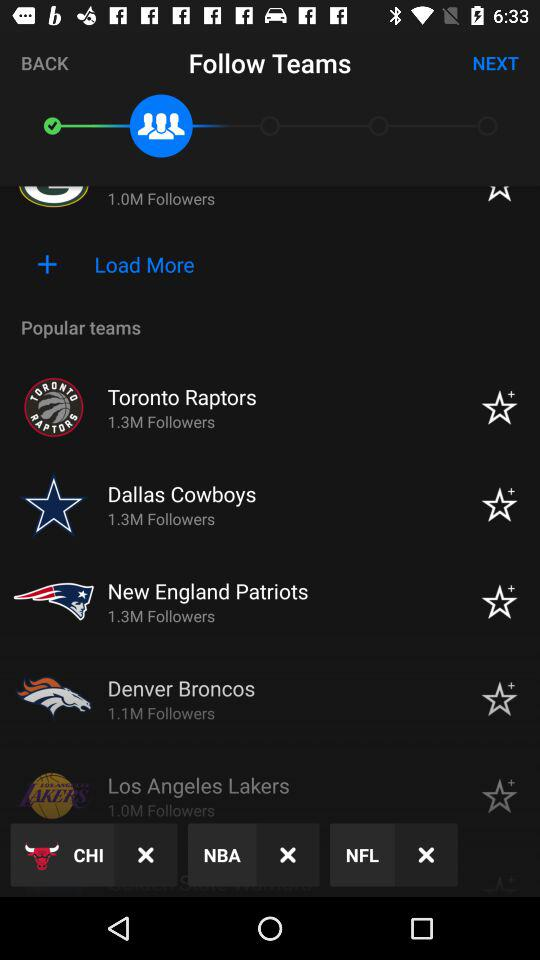What are the different team names? The different team names are : "Toronto Raptors", "Dallas Cowboys", "New England Patriots", "Denver Broncos", and "Los Angeles Lakers". 